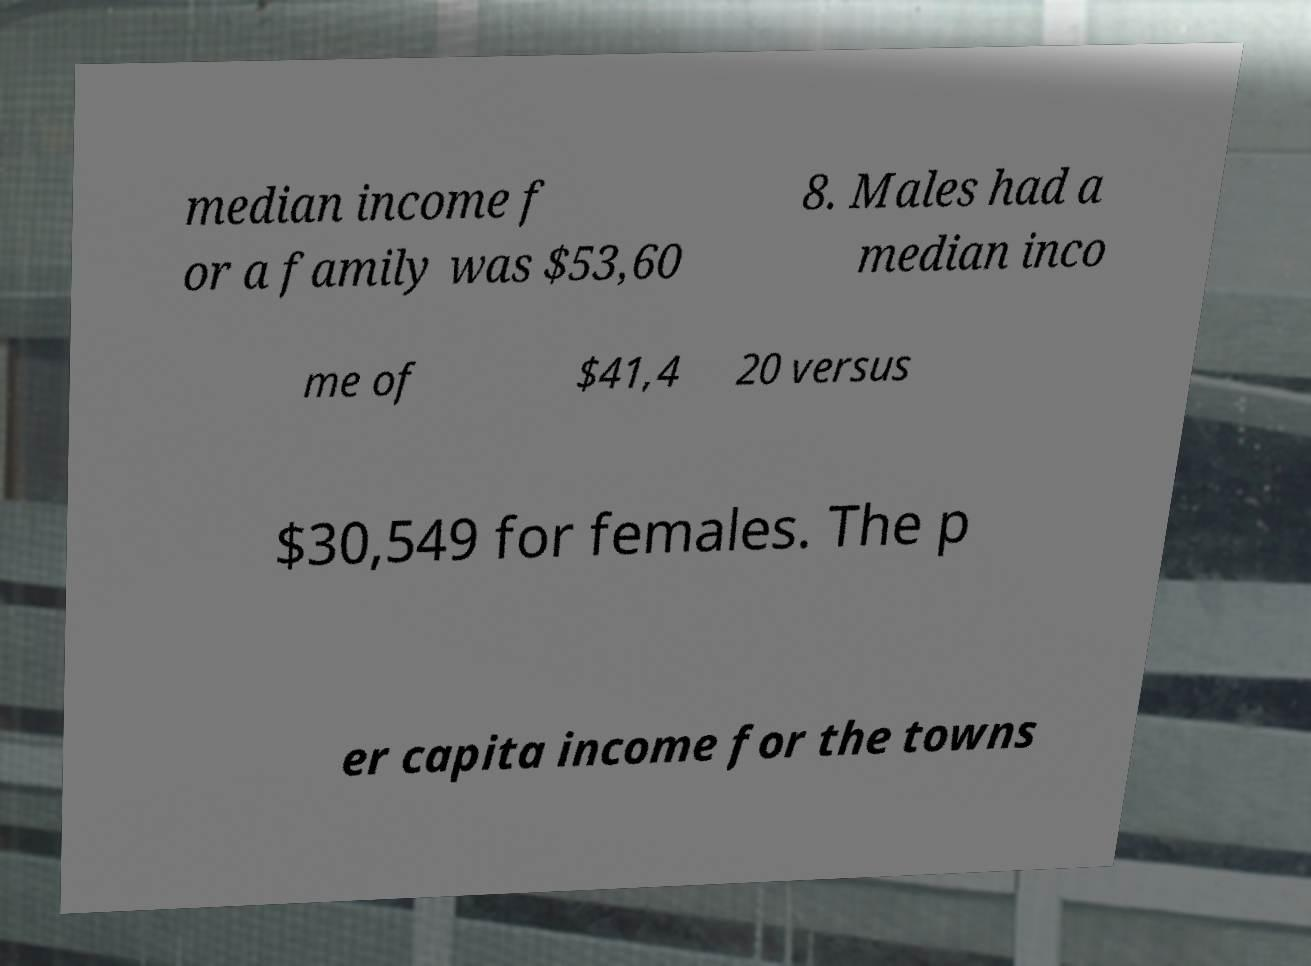Could you assist in decoding the text presented in this image and type it out clearly? median income f or a family was $53,60 8. Males had a median inco me of $41,4 20 versus $30,549 for females. The p er capita income for the towns 